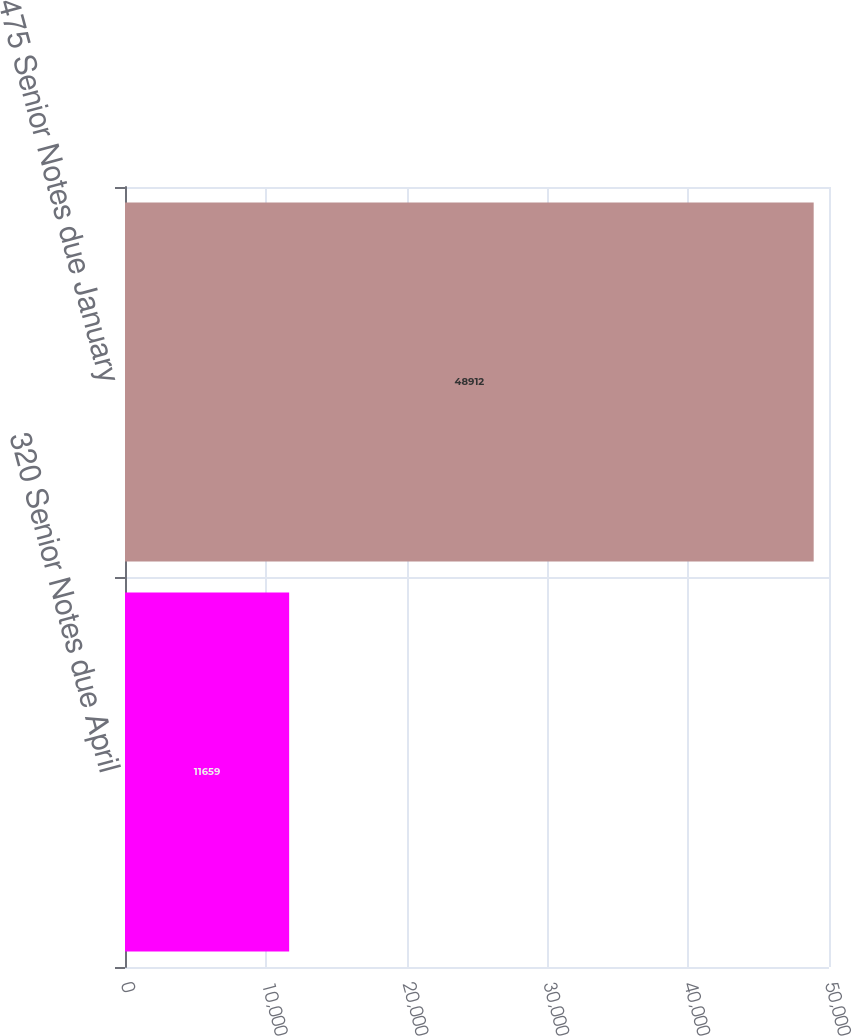Convert chart. <chart><loc_0><loc_0><loc_500><loc_500><bar_chart><fcel>320 Senior Notes due April<fcel>475 Senior Notes due January<nl><fcel>11659<fcel>48912<nl></chart> 